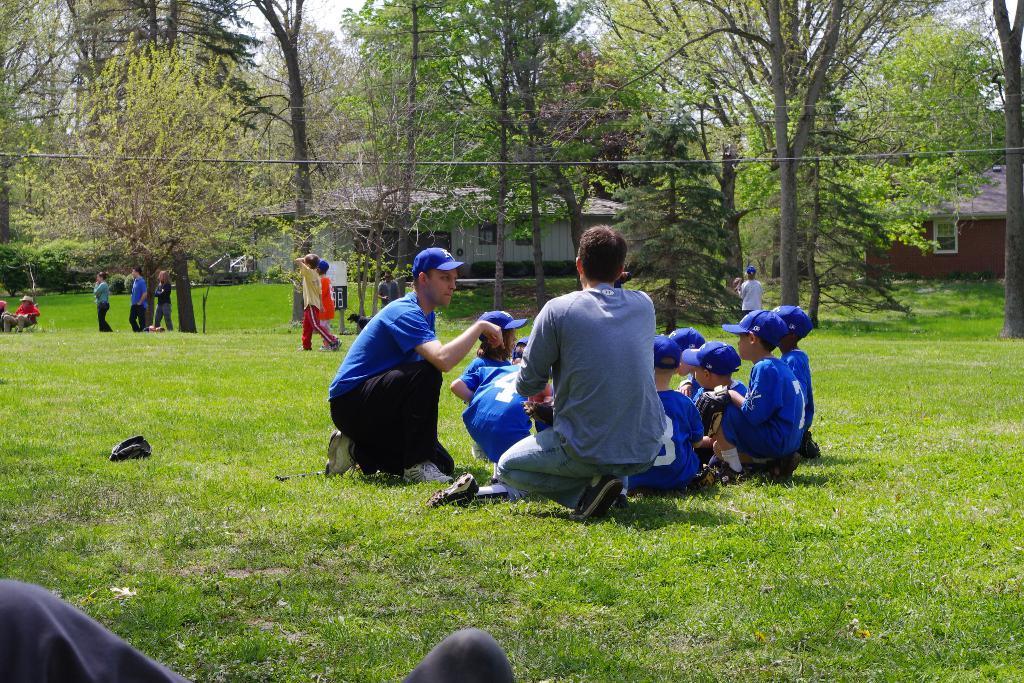Please provide a concise description of this image. At the bottom, we see the grass and the leg of the person who is wearing the grey pant. In the middle, we see the people are sitting on the grass. Behind them, we see a dog and the people are standing. Beside them, we see a garbage bin in black color. On the left side, we see a man is sitting on the chair. Behind him, we see the people are standing. There are trees and the buildings in the background. 